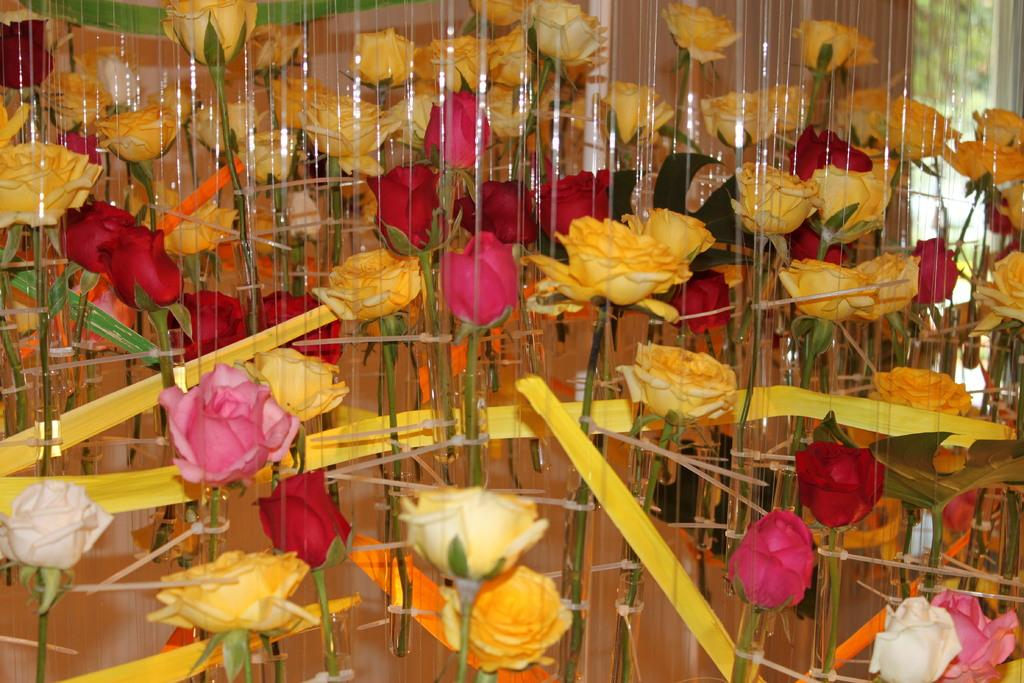What type of flowers are present in the image? There are rose flowers in the image. What other objects can be seen in the image besides the flowers? There are ribbons in the image. What is visible in the background of the image? There is a curtain in the background of the image. How does the dirt start to fly in the image? There is no dirt or flying in the image; it only features rose flowers, ribbons, and a curtain. 